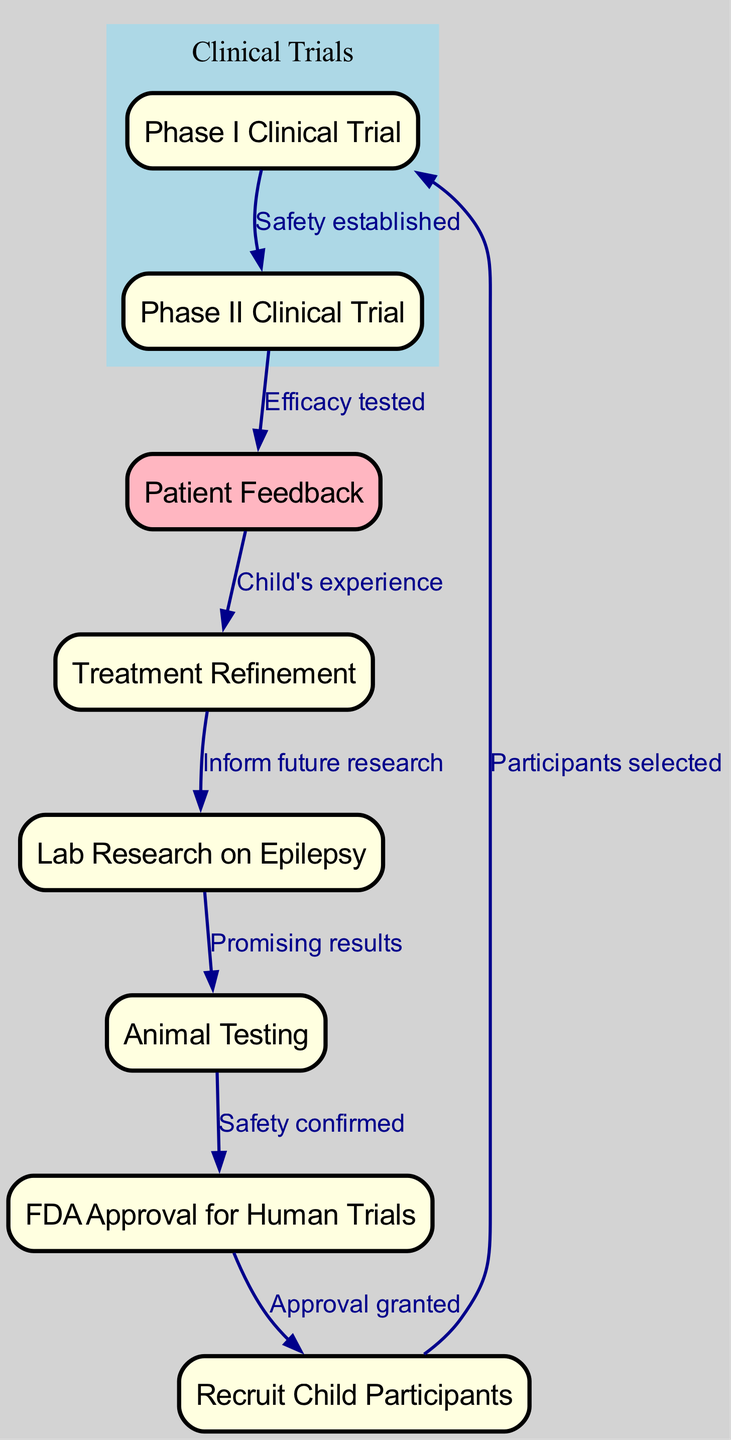What is the first step in the treatment journey? The diagram indicates that "Lab Research on Epilepsy" is the first node, which signifies the initiation of the treatment journey.
Answer: Lab Research on Epilepsy How many phases of clinical trials are there? The diagram shows two distinct nodes labeled "Phase I Clinical Trial" and "Phase II Clinical Trial," indicating that there are two phases in total.
Answer: 2 What follows animal testing? According to the flow chart, the progression after "Animal Testing" is "FDA Approval for Human Trials," as indicated by the directed edge connecting these two nodes.
Answer: FDA Approval for Human Trials What is the relationship between patient feedback and treatment refinement? The diagram illustrates that "Patient Feedback" leads to "Treatment Refinement," indicating a directional flow where feedback informs the improvement of treatment.
Answer: Patient Feedback leads to Treatment Refinement What is the significance of recruiting child participants? The edge connects "FDA Approval for Human Trials" to "Recruit Child Participants," indicating that only after approval can child participants be recruited for trials.
Answer: Approval granted before recruiting participants How does a child's experience influence future research? The diagram specifies that "Treatment Refinement" results in informing "Lab Research on Epilepsy." This means that insights gained from a child's experience feed back into enhancing future research efforts.
Answer: Child's experience informs future research Which node is highlighted in light pink? The diagram explicitly highlights "Patient Feedback" by coloring it in light pink, distinguishing it from other nodes to indicate its importance in the treatment process.
Answer: Patient Feedback What is the purpose of animal testing in this journey? The connection from "Lab Research on Epilepsy" to "Animal Testing" labeled "Promising results" implies that animal testing is utilized to confirm that initial research findings show potential before moving on to human trials.
Answer: Safety confirmed before human trials What indicates a successful transition from Phase I to Phase II trials? The flow from "Phase I Clinical Trial" to "Phase II Clinical Trial" marked by "Safety established" indicates that the transition occurs only after ensuring the safety of the treatment.
Answer: Safety established 